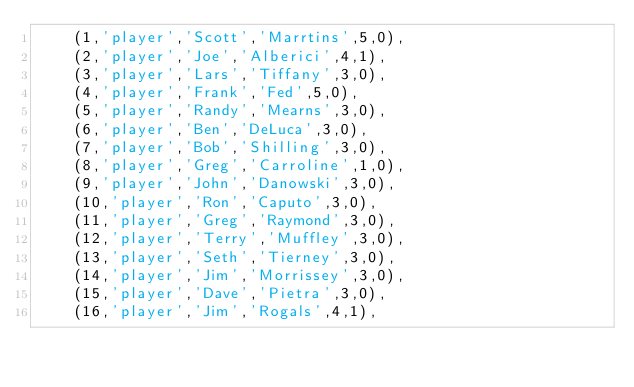Convert code to text. <code><loc_0><loc_0><loc_500><loc_500><_SQL_>	(1,'player','Scott','Marrtins',5,0),
	(2,'player','Joe','Alberici',4,1),
	(3,'player','Lars','Tiffany',3,0),
	(4,'player','Frank','Fed',5,0),
	(5,'player','Randy','Mearns',3,0),
	(6,'player','Ben','DeLuca',3,0),
	(7,'player','Bob','Shilling',3,0),
	(8,'player','Greg','Carroline',1,0),
	(9,'player','John','Danowski',3,0),
	(10,'player','Ron','Caputo',3,0),
	(11,'player','Greg','Raymond',3,0),
	(12,'player','Terry','Muffley',3,0),
	(13,'player','Seth','Tierney',3,0),
	(14,'player','Jim','Morrissey',3,0),
	(15,'player','Dave','Pietra',3,0),
	(16,'player','Jim','Rogals',4,1),</code> 